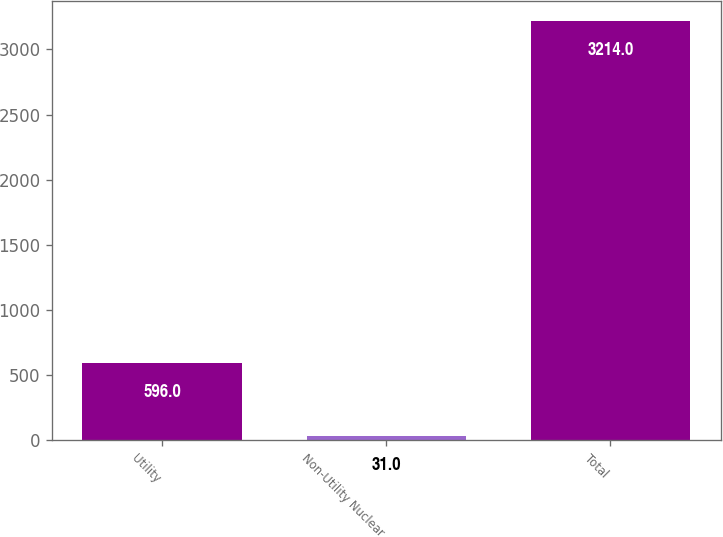<chart> <loc_0><loc_0><loc_500><loc_500><bar_chart><fcel>Utility<fcel>Non-Utility Nuclear<fcel>Total<nl><fcel>596<fcel>31<fcel>3214<nl></chart> 